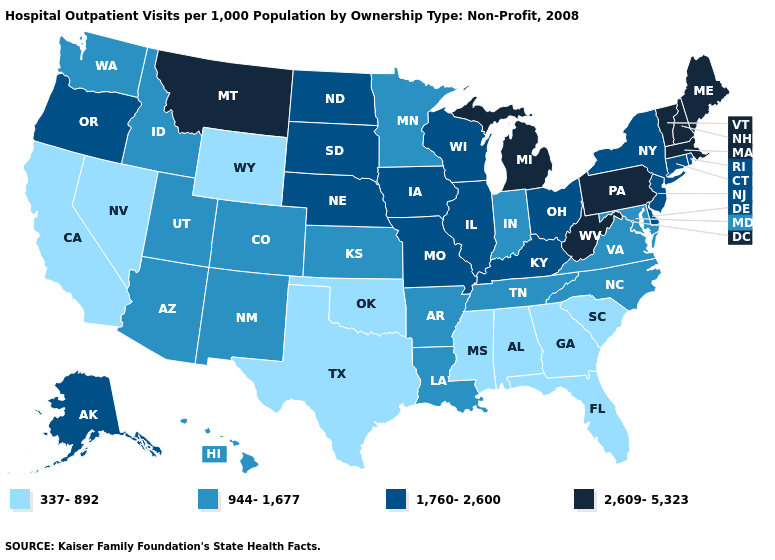Does Kentucky have the highest value in the South?
Write a very short answer. No. What is the lowest value in states that border Tennessee?
Be succinct. 337-892. Name the states that have a value in the range 337-892?
Write a very short answer. Alabama, California, Florida, Georgia, Mississippi, Nevada, Oklahoma, South Carolina, Texas, Wyoming. Name the states that have a value in the range 337-892?
Write a very short answer. Alabama, California, Florida, Georgia, Mississippi, Nevada, Oklahoma, South Carolina, Texas, Wyoming. Name the states that have a value in the range 2,609-5,323?
Concise answer only. Maine, Massachusetts, Michigan, Montana, New Hampshire, Pennsylvania, Vermont, West Virginia. What is the lowest value in the USA?
Short answer required. 337-892. What is the value of Rhode Island?
Concise answer only. 1,760-2,600. What is the value of Nebraska?
Quick response, please. 1,760-2,600. Name the states that have a value in the range 2,609-5,323?
Quick response, please. Maine, Massachusetts, Michigan, Montana, New Hampshire, Pennsylvania, Vermont, West Virginia. Among the states that border Washington , which have the lowest value?
Give a very brief answer. Idaho. Name the states that have a value in the range 2,609-5,323?
Answer briefly. Maine, Massachusetts, Michigan, Montana, New Hampshire, Pennsylvania, Vermont, West Virginia. What is the value of New Mexico?
Keep it brief. 944-1,677. Which states hav the highest value in the Northeast?
Write a very short answer. Maine, Massachusetts, New Hampshire, Pennsylvania, Vermont. Does South Carolina have the same value as Mississippi?
Concise answer only. Yes. 